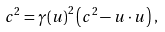Convert formula to latex. <formula><loc_0><loc_0><loc_500><loc_500>c ^ { 2 } = { \gamma ( u ) } ^ { 2 } \left ( c ^ { 2 } - u \cdot u \right ) \, ,</formula> 